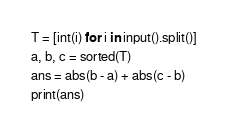<code> <loc_0><loc_0><loc_500><loc_500><_Python_>T = [int(i) for i in input().split()]
a, b, c = sorted(T)
ans = abs(b - a) + abs(c - b)
print(ans)</code> 